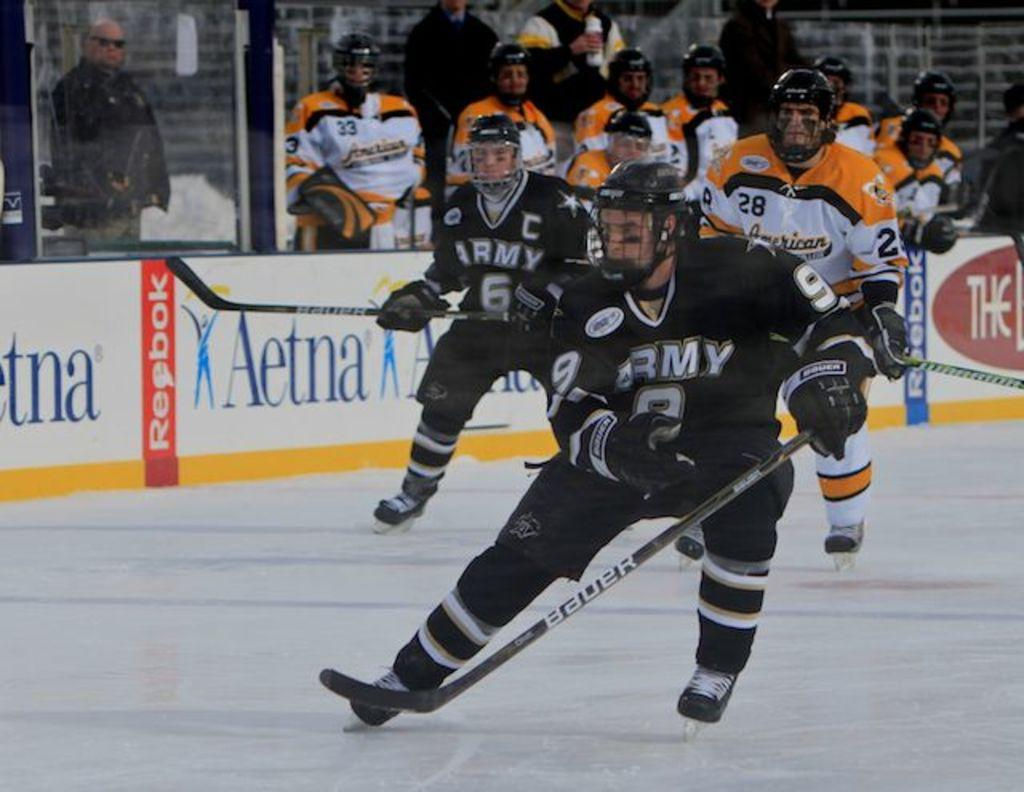<image>
Share a concise interpretation of the image provided. Hockey players on the ice with banners from Aetna and Reebok on the sideline wall 